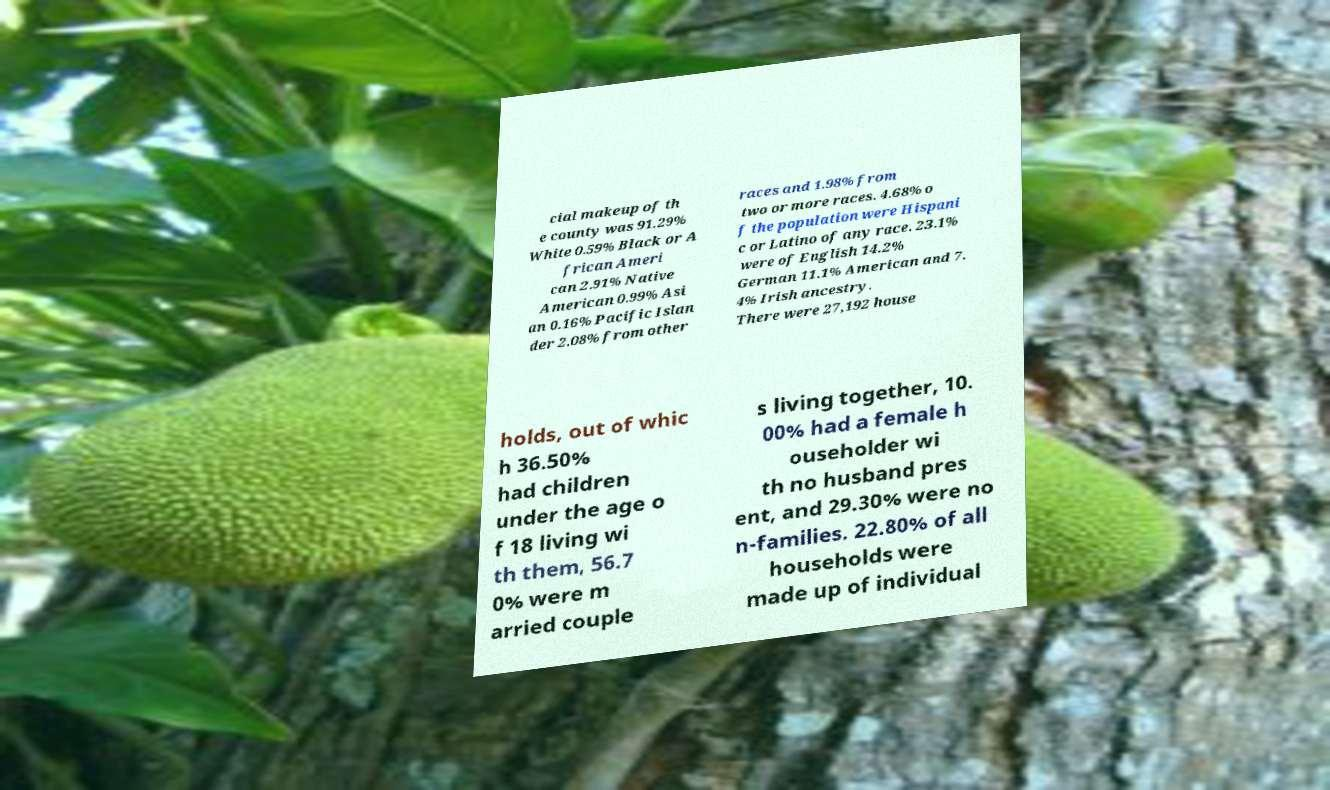Could you extract and type out the text from this image? cial makeup of th e county was 91.29% White 0.59% Black or A frican Ameri can 2.91% Native American 0.99% Asi an 0.16% Pacific Islan der 2.08% from other races and 1.98% from two or more races. 4.68% o f the population were Hispani c or Latino of any race. 23.1% were of English 14.2% German 11.1% American and 7. 4% Irish ancestry. There were 27,192 house holds, out of whic h 36.50% had children under the age o f 18 living wi th them, 56.7 0% were m arried couple s living together, 10. 00% had a female h ouseholder wi th no husband pres ent, and 29.30% were no n-families. 22.80% of all households were made up of individual 